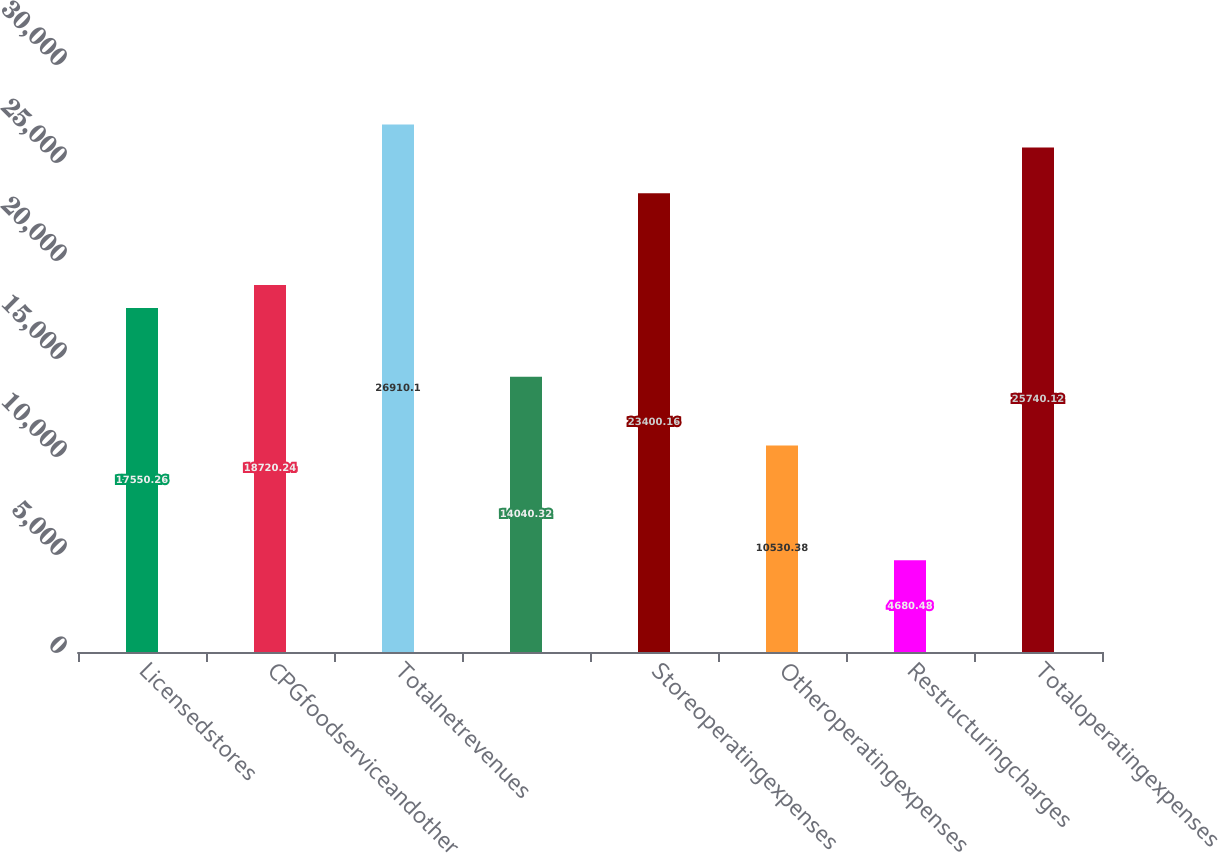Convert chart to OTSL. <chart><loc_0><loc_0><loc_500><loc_500><bar_chart><fcel>Licensedstores<fcel>CPGfoodserviceandother<fcel>Totalnetrevenues<fcel>Unnamed: 3<fcel>Storeoperatingexpenses<fcel>Otheroperatingexpenses<fcel>Restructuringcharges<fcel>Totaloperatingexpenses<nl><fcel>17550.3<fcel>18720.2<fcel>26910.1<fcel>14040.3<fcel>23400.2<fcel>10530.4<fcel>4680.48<fcel>25740.1<nl></chart> 